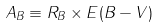<formula> <loc_0><loc_0><loc_500><loc_500>A _ { B } \equiv R _ { B } \times E ( B - V )</formula> 